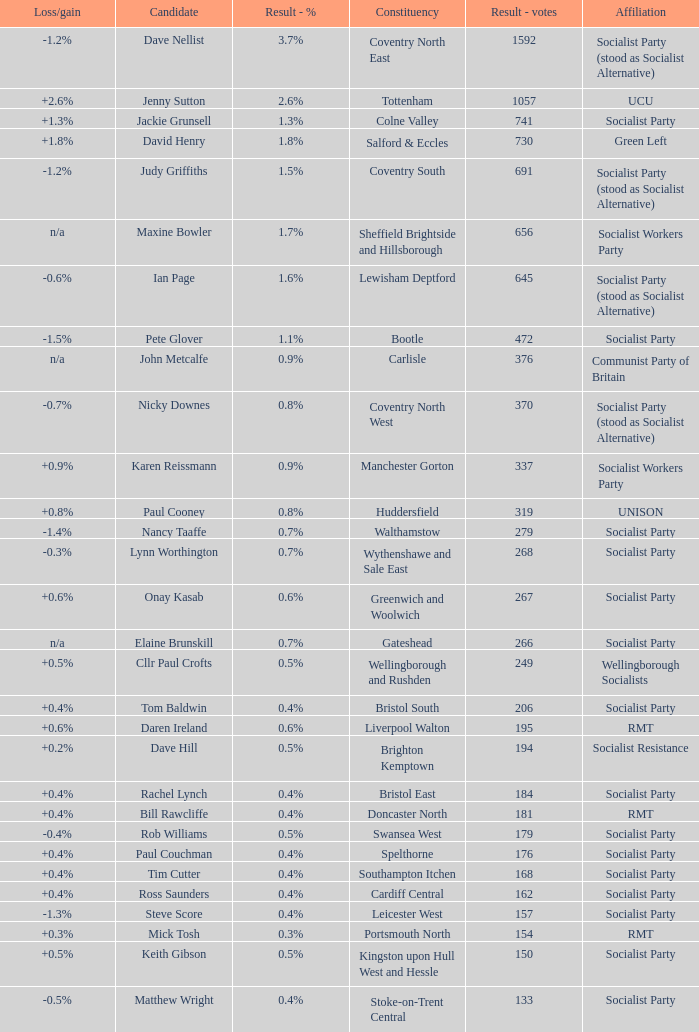What is the largest vote result if loss/gain is -0.5%? 133.0. Would you be able to parse every entry in this table? {'header': ['Loss/gain', 'Candidate', 'Result - %', 'Constituency', 'Result - votes', 'Affiliation'], 'rows': [['-1.2%', 'Dave Nellist', '3.7%', 'Coventry North East', '1592', 'Socialist Party (stood as Socialist Alternative)'], ['+2.6%', 'Jenny Sutton', '2.6%', 'Tottenham', '1057', 'UCU'], ['+1.3%', 'Jackie Grunsell', '1.3%', 'Colne Valley', '741', 'Socialist Party'], ['+1.8%', 'David Henry', '1.8%', 'Salford & Eccles', '730', 'Green Left'], ['-1.2%', 'Judy Griffiths', '1.5%', 'Coventry South', '691', 'Socialist Party (stood as Socialist Alternative)'], ['n/a', 'Maxine Bowler', '1.7%', 'Sheffield Brightside and Hillsborough', '656', 'Socialist Workers Party'], ['-0.6%', 'Ian Page', '1.6%', 'Lewisham Deptford', '645', 'Socialist Party (stood as Socialist Alternative)'], ['-1.5%', 'Pete Glover', '1.1%', 'Bootle', '472', 'Socialist Party'], ['n/a', 'John Metcalfe', '0.9%', 'Carlisle', '376', 'Communist Party of Britain'], ['-0.7%', 'Nicky Downes', '0.8%', 'Coventry North West', '370', 'Socialist Party (stood as Socialist Alternative)'], ['+0.9%', 'Karen Reissmann', '0.9%', 'Manchester Gorton', '337', 'Socialist Workers Party'], ['+0.8%', 'Paul Cooney', '0.8%', 'Huddersfield', '319', 'UNISON'], ['-1.4%', 'Nancy Taaffe', '0.7%', 'Walthamstow', '279', 'Socialist Party'], ['-0.3%', 'Lynn Worthington', '0.7%', 'Wythenshawe and Sale East', '268', 'Socialist Party'], ['+0.6%', 'Onay Kasab', '0.6%', 'Greenwich and Woolwich', '267', 'Socialist Party'], ['n/a', 'Elaine Brunskill', '0.7%', 'Gateshead', '266', 'Socialist Party'], ['+0.5%', 'Cllr Paul Crofts', '0.5%', 'Wellingborough and Rushden', '249', 'Wellingborough Socialists'], ['+0.4%', 'Tom Baldwin', '0.4%', 'Bristol South', '206', 'Socialist Party'], ['+0.6%', 'Daren Ireland', '0.6%', 'Liverpool Walton', '195', 'RMT'], ['+0.2%', 'Dave Hill', '0.5%', 'Brighton Kemptown', '194', 'Socialist Resistance'], ['+0.4%', 'Rachel Lynch', '0.4%', 'Bristol East', '184', 'Socialist Party'], ['+0.4%', 'Bill Rawcliffe', '0.4%', 'Doncaster North', '181', 'RMT'], ['-0.4%', 'Rob Williams', '0.5%', 'Swansea West', '179', 'Socialist Party'], ['+0.4%', 'Paul Couchman', '0.4%', 'Spelthorne', '176', 'Socialist Party'], ['+0.4%', 'Tim Cutter', '0.4%', 'Southampton Itchen', '168', 'Socialist Party'], ['+0.4%', 'Ross Saunders', '0.4%', 'Cardiff Central', '162', 'Socialist Party'], ['-1.3%', 'Steve Score', '0.4%', 'Leicester West', '157', 'Socialist Party'], ['+0.3%', 'Mick Tosh', '0.3%', 'Portsmouth North', '154', 'RMT'], ['+0.5%', 'Keith Gibson', '0.5%', 'Kingston upon Hull West and Hessle', '150', 'Socialist Party'], ['-0.5%', 'Matthew Wright', '0.4%', 'Stoke-on-Trent Central', '133', 'Socialist Party']]} 